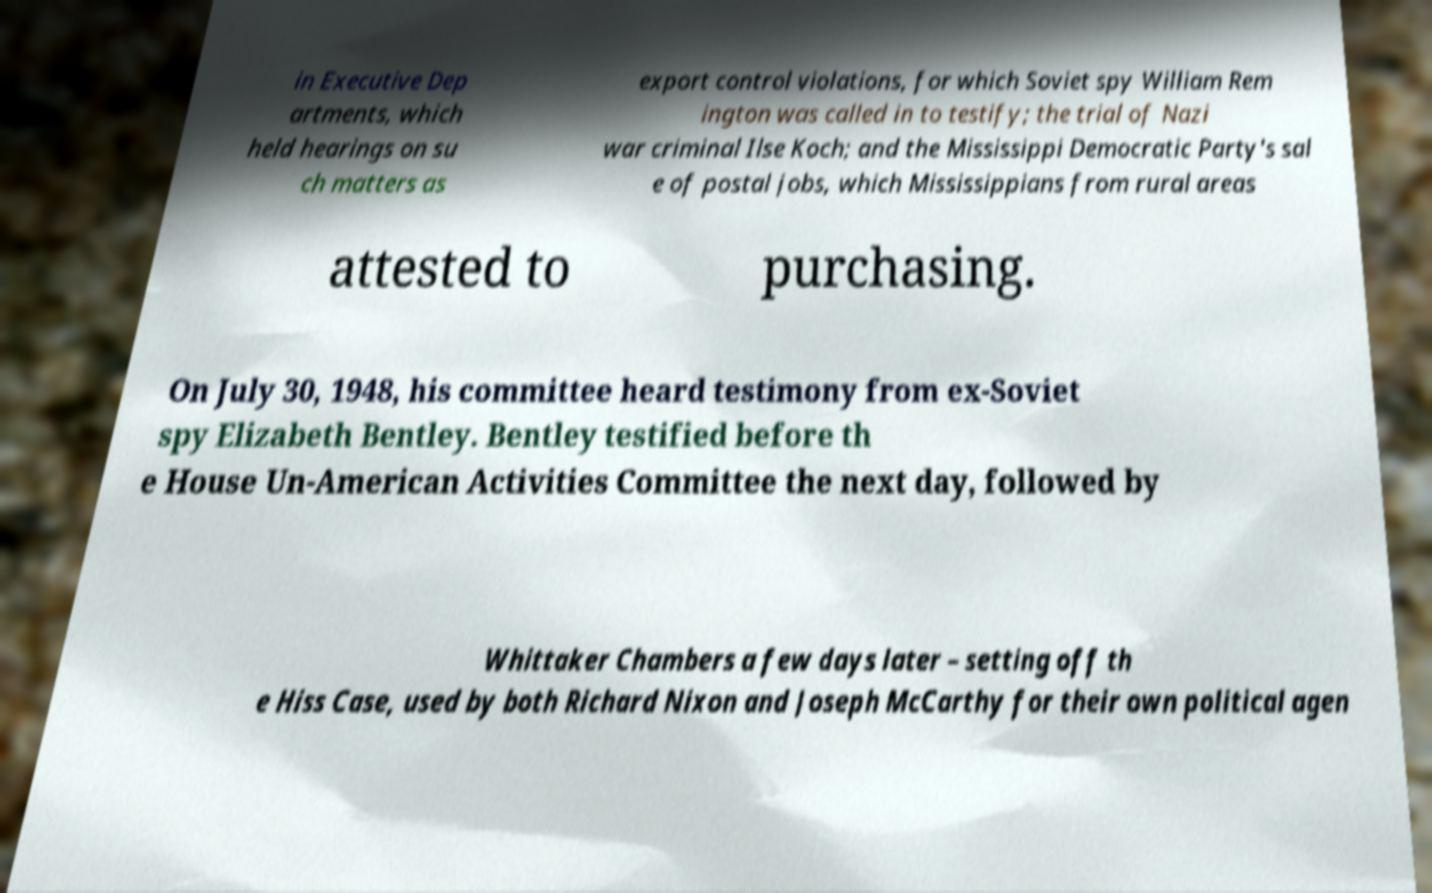There's text embedded in this image that I need extracted. Can you transcribe it verbatim? in Executive Dep artments, which held hearings on su ch matters as export control violations, for which Soviet spy William Rem ington was called in to testify; the trial of Nazi war criminal Ilse Koch; and the Mississippi Democratic Party's sal e of postal jobs, which Mississippians from rural areas attested to purchasing. On July 30, 1948, his committee heard testimony from ex-Soviet spy Elizabeth Bentley. Bentley testified before th e House Un-American Activities Committee the next day, followed by Whittaker Chambers a few days later – setting off th e Hiss Case, used by both Richard Nixon and Joseph McCarthy for their own political agen 